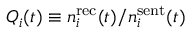Convert formula to latex. <formula><loc_0><loc_0><loc_500><loc_500>Q _ { i } ( t ) \equiv n _ { i } ^ { r e c } ( t ) / n _ { i } ^ { s e n t } ( t )</formula> 